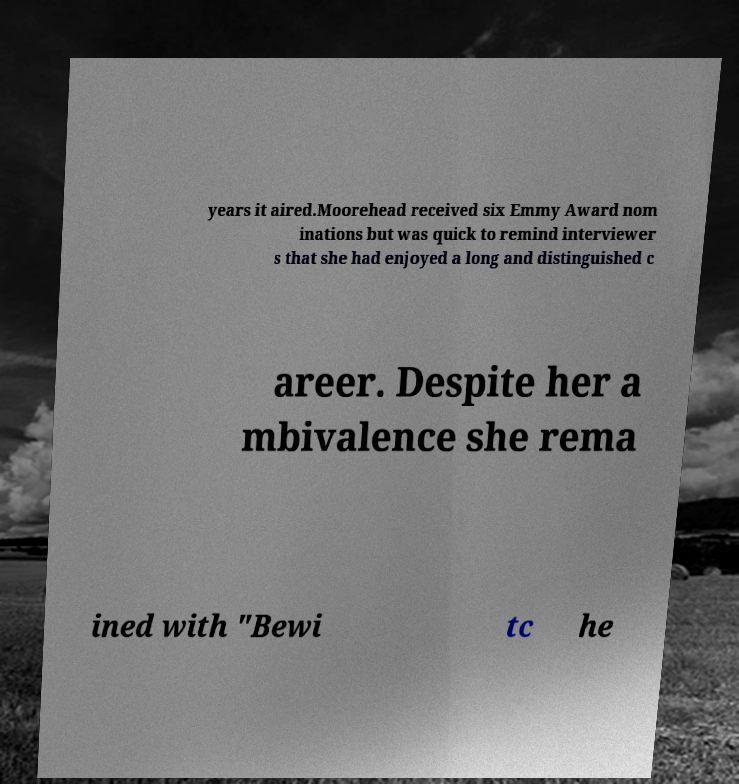There's text embedded in this image that I need extracted. Can you transcribe it verbatim? years it aired.Moorehead received six Emmy Award nom inations but was quick to remind interviewer s that she had enjoyed a long and distinguished c areer. Despite her a mbivalence she rema ined with "Bewi tc he 